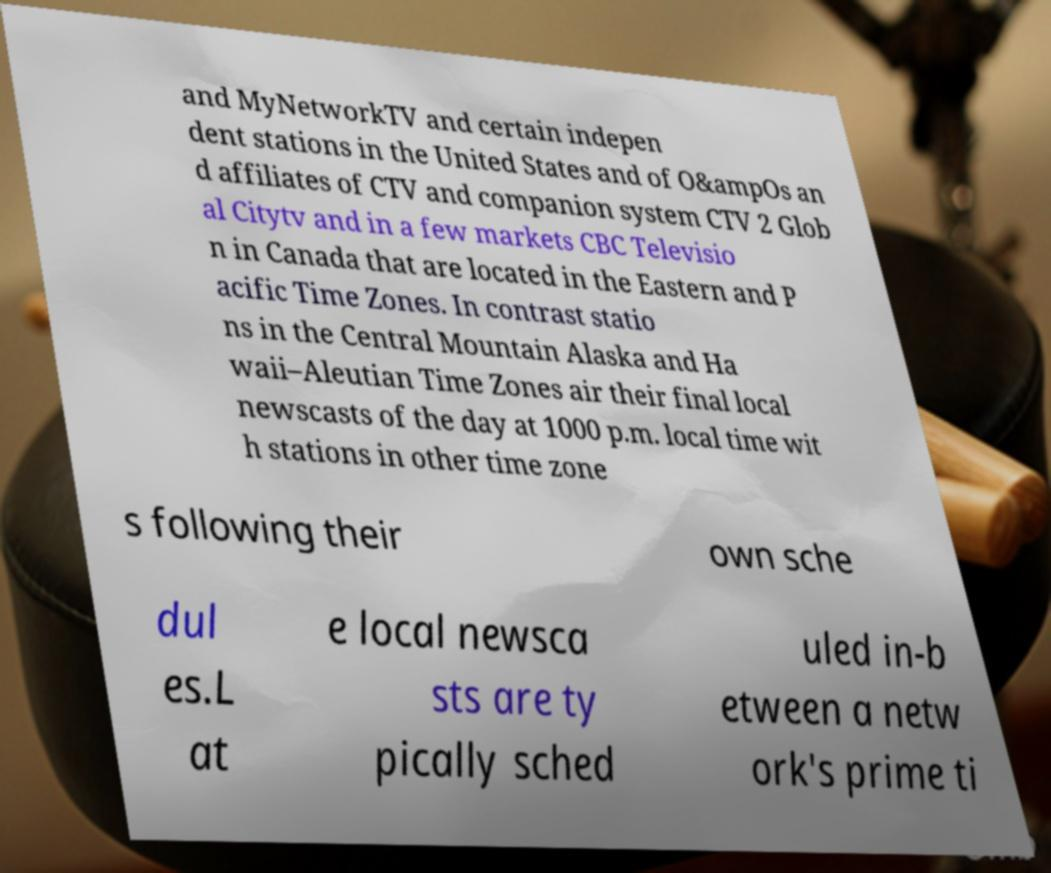Can you accurately transcribe the text from the provided image for me? and MyNetworkTV and certain indepen dent stations in the United States and of O&ampOs an d affiliates of CTV and companion system CTV 2 Glob al Citytv and in a few markets CBC Televisio n in Canada that are located in the Eastern and P acific Time Zones. In contrast statio ns in the Central Mountain Alaska and Ha waii–Aleutian Time Zones air their final local newscasts of the day at 1000 p.m. local time wit h stations in other time zone s following their own sche dul es.L at e local newsca sts are ty pically sched uled in-b etween a netw ork's prime ti 